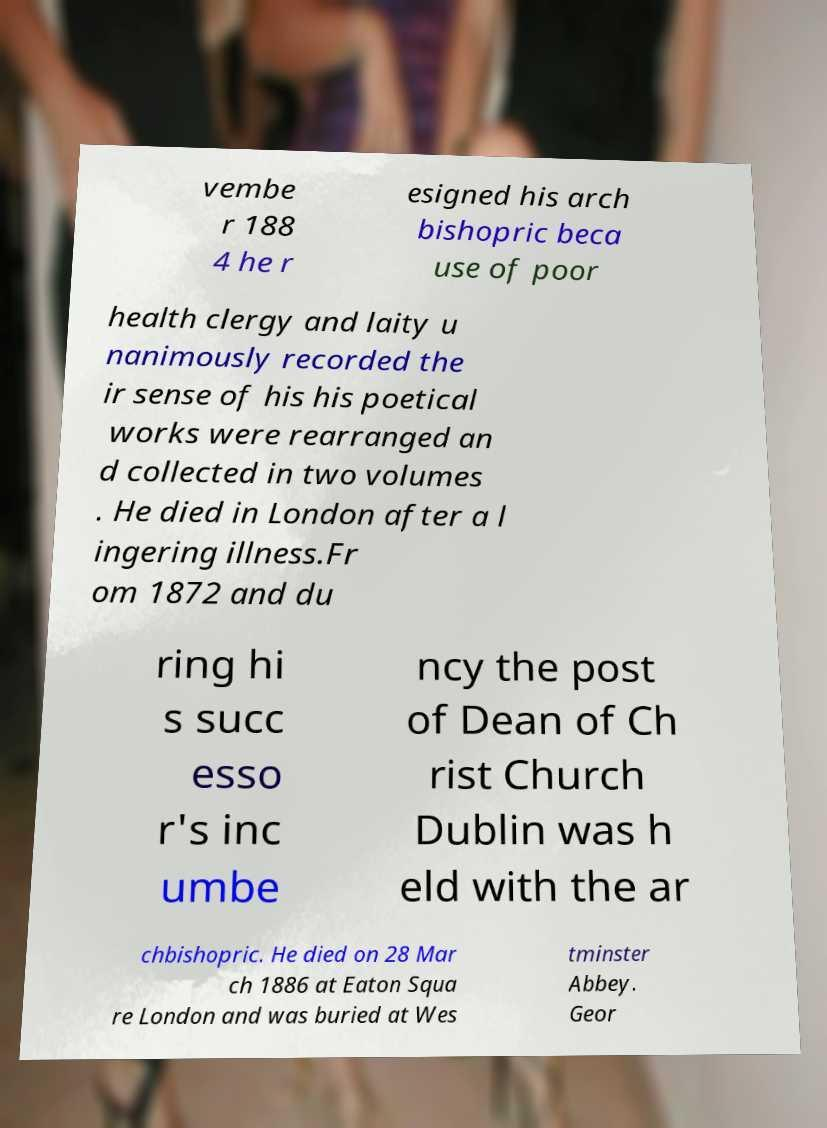What messages or text are displayed in this image? I need them in a readable, typed format. vembe r 188 4 he r esigned his arch bishopric beca use of poor health clergy and laity u nanimously recorded the ir sense of his his poetical works were rearranged an d collected in two volumes . He died in London after a l ingering illness.Fr om 1872 and du ring hi s succ esso r's inc umbe ncy the post of Dean of Ch rist Church Dublin was h eld with the ar chbishopric. He died on 28 Mar ch 1886 at Eaton Squa re London and was buried at Wes tminster Abbey. Geor 